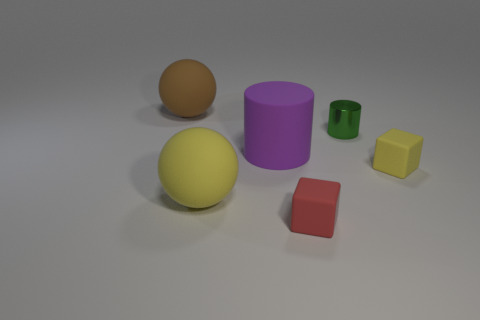The yellow rubber sphere is what size?
Provide a succinct answer. Large. How many other cylinders have the same color as the large matte cylinder?
Ensure brevity in your answer.  0. Do the red rubber cube and the green metal thing have the same size?
Your answer should be very brief. Yes. What is the size of the rubber ball that is in front of the large object that is right of the large yellow object?
Offer a very short reply. Large. There is a tiny shiny cylinder; does it have the same color as the ball right of the big brown rubber object?
Make the answer very short. No. Are there any brown rubber spheres that have the same size as the purple thing?
Keep it short and to the point. Yes. What size is the rubber ball that is in front of the large purple cylinder?
Provide a short and direct response. Large. Is there a matte cube behind the matte block right of the small red block?
Make the answer very short. No. How many other objects are the same shape as the big brown object?
Your response must be concise. 1. Is the shape of the brown rubber thing the same as the purple matte object?
Offer a very short reply. No. 